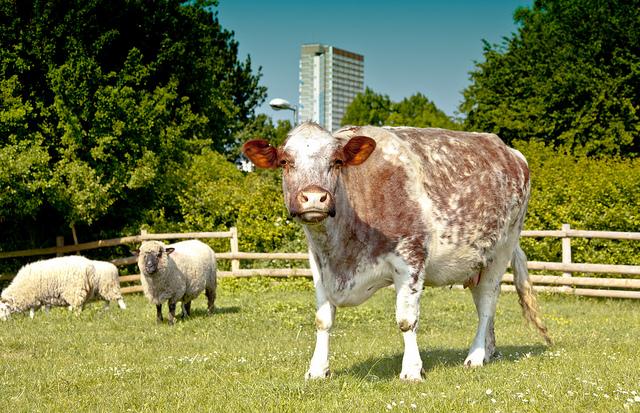Is this taken in Winter?
Quick response, please. No. What color is the fence?
Write a very short answer. Tan. What animals are in the  pen?
Write a very short answer. Sheep and cow. What is the weather like?
Concise answer only. Sunny. 